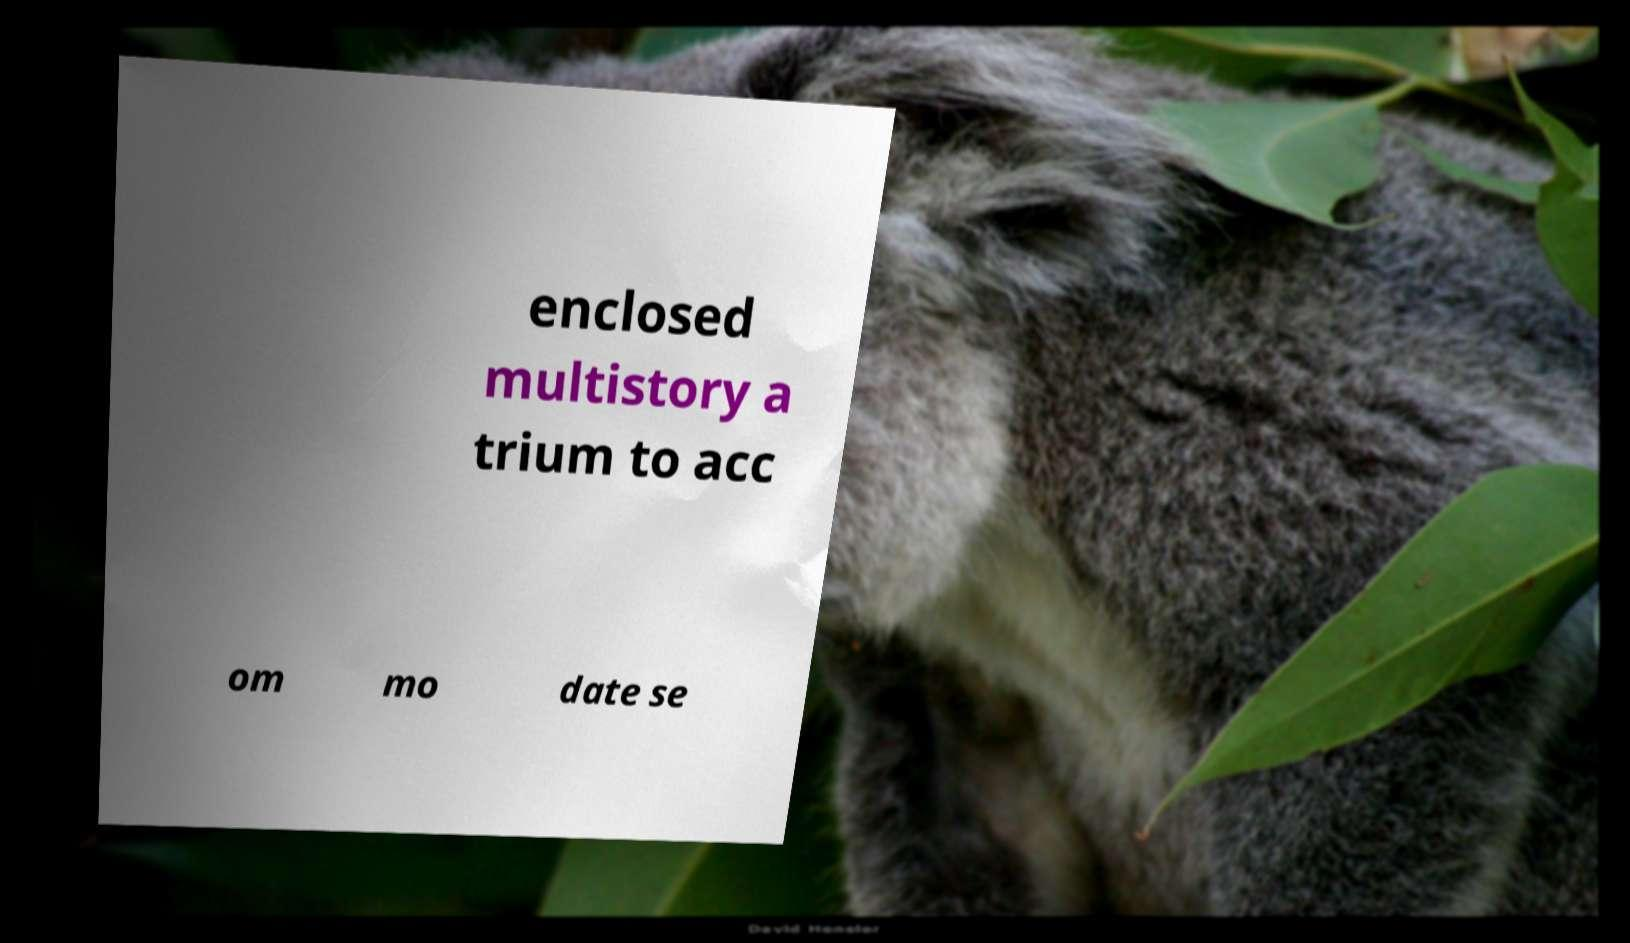For documentation purposes, I need the text within this image transcribed. Could you provide that? enclosed multistory a trium to acc om mo date se 